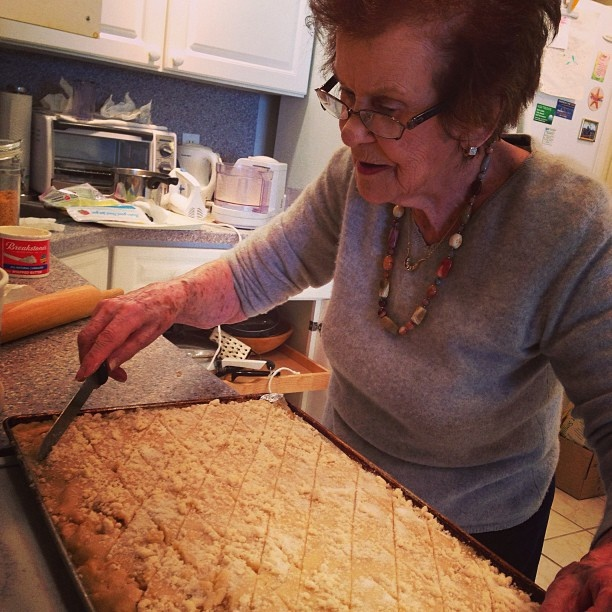Describe the objects in this image and their specific colors. I can see people in tan, maroon, black, and brown tones, cake in tan, brown, maroon, and salmon tones, refrigerator in tan, lightgray, and darkgray tones, microwave in tan, black, and gray tones, and oven in tan, black, gray, and maroon tones in this image. 